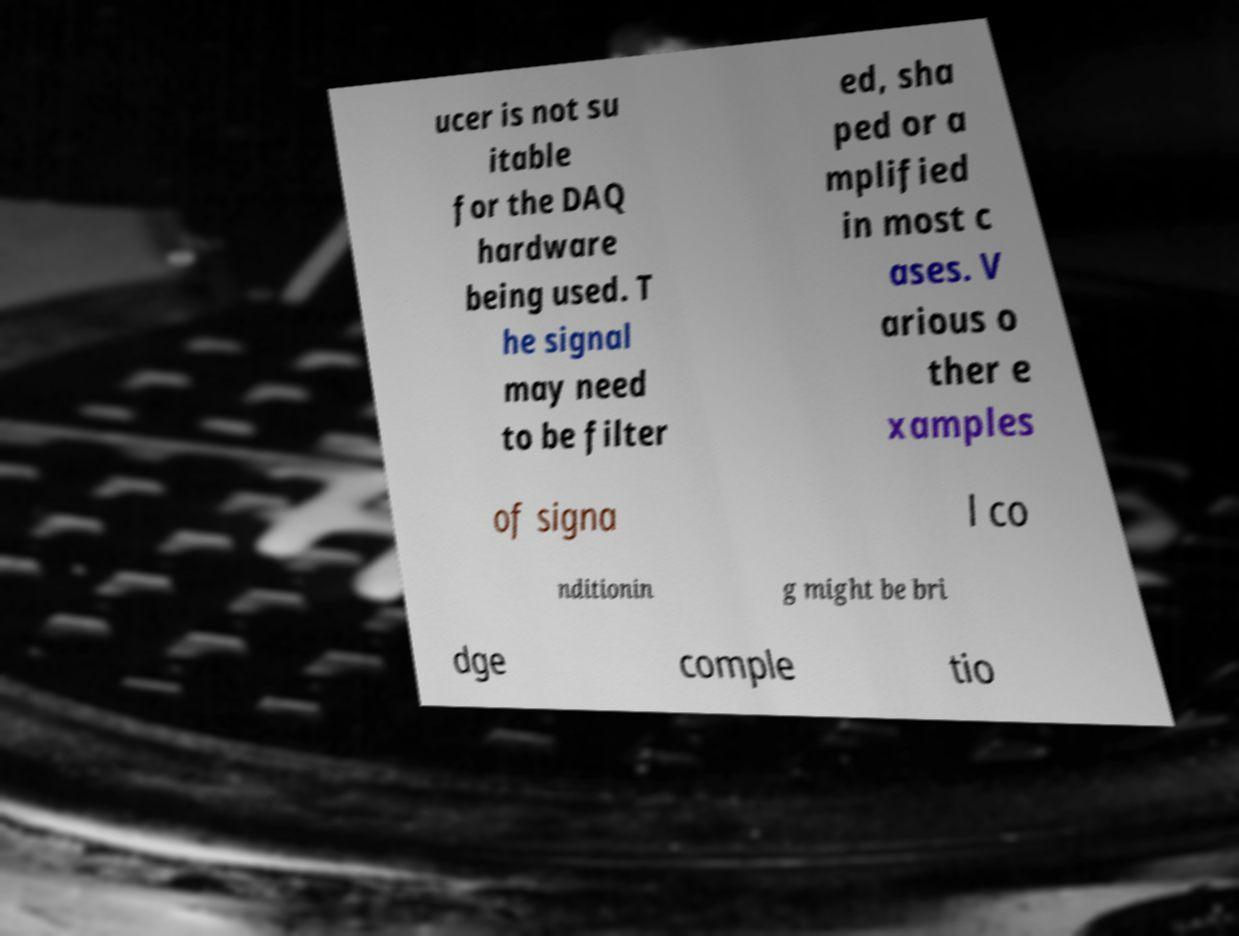For documentation purposes, I need the text within this image transcribed. Could you provide that? ucer is not su itable for the DAQ hardware being used. T he signal may need to be filter ed, sha ped or a mplified in most c ases. V arious o ther e xamples of signa l co nditionin g might be bri dge comple tio 